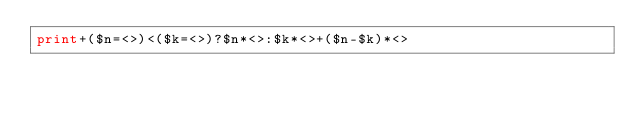Convert code to text. <code><loc_0><loc_0><loc_500><loc_500><_Perl_>print+($n=<>)<($k=<>)?$n*<>:$k*<>+($n-$k)*<></code> 